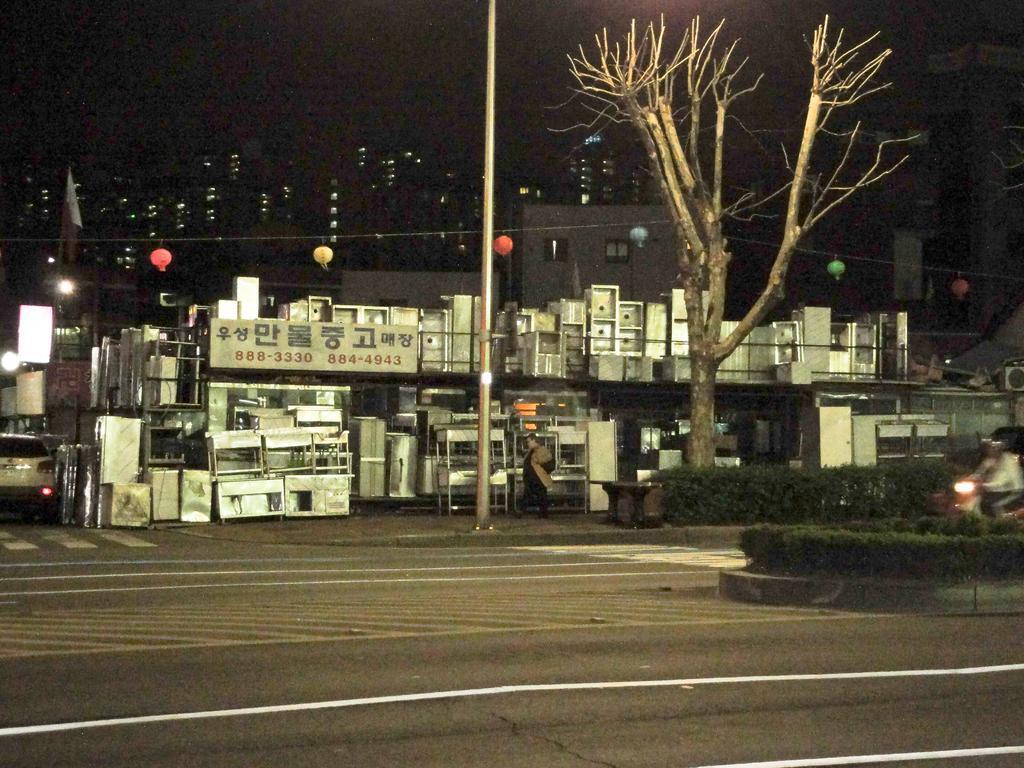How would you summarize this image in a sentence or two? In this image, we can see a dry tree in front of the shop. There is a person on the right side of the image riding a bike in between plants. There is a pole on the road. There are some buildings in the middle of the image. There is a car on the left side of the image. There is a sky at the top of the image. 